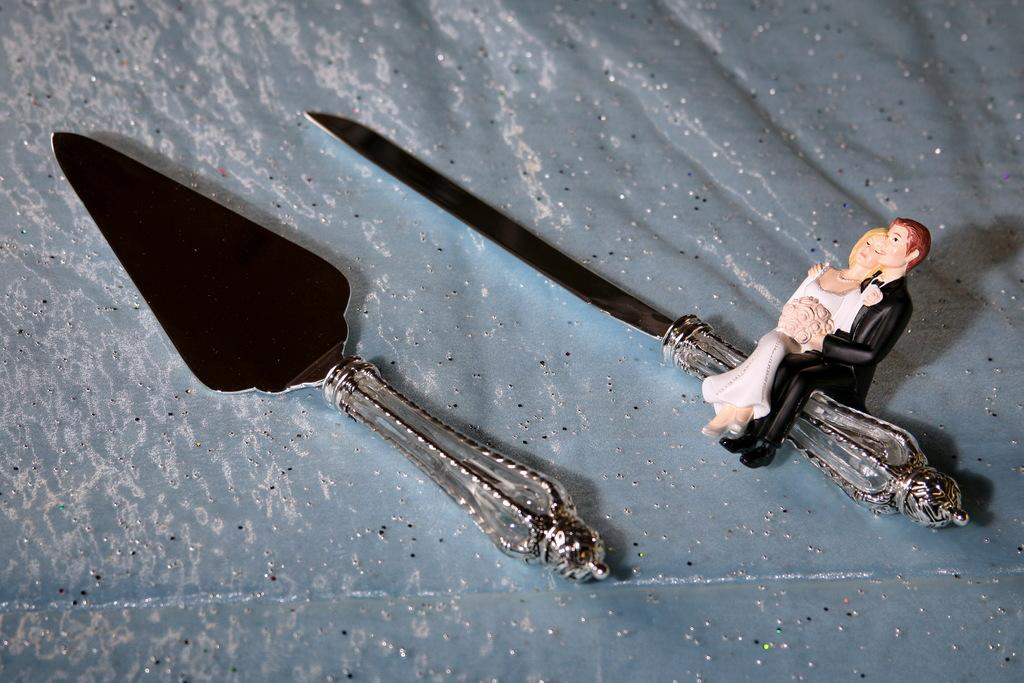What objects are placed on the cloth in the image? There are two knives on a cloth in the image. What type of toys can be seen in the image? There are toys of a couple in the image. What is one of the toys holding? One of the toys appears to be holding a knife. How many chickens are present in the image? There are no chickens present in the image. What type of test is being conducted in the image? There is no test being conducted in the image. 